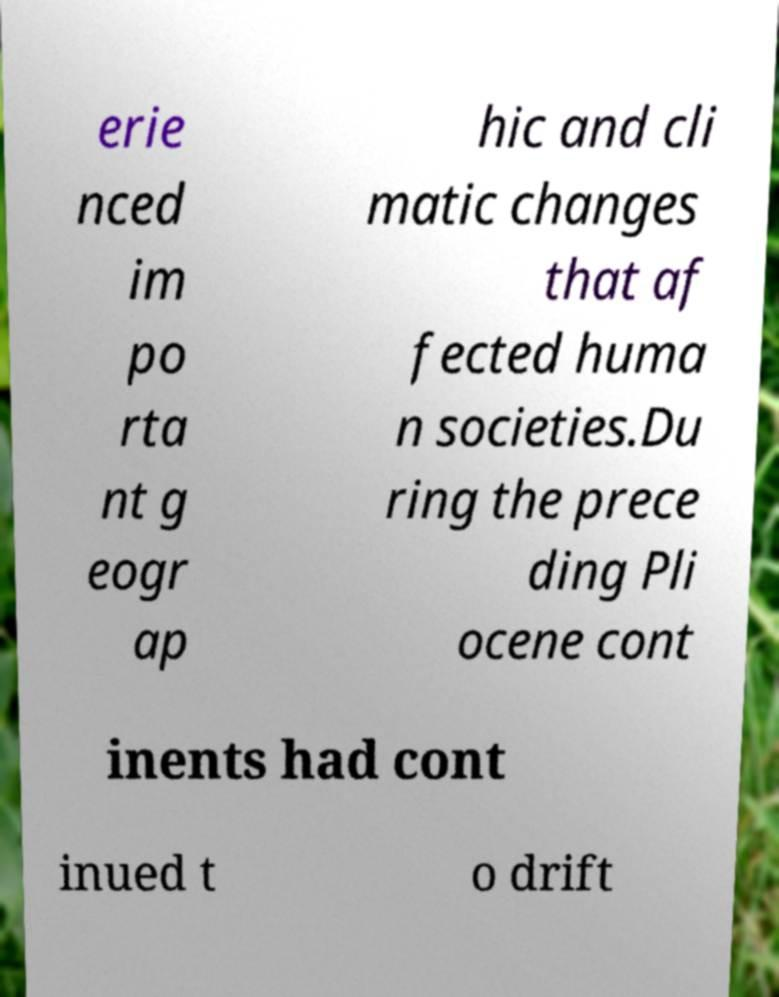Could you extract and type out the text from this image? erie nced im po rta nt g eogr ap hic and cli matic changes that af fected huma n societies.Du ring the prece ding Pli ocene cont inents had cont inued t o drift 